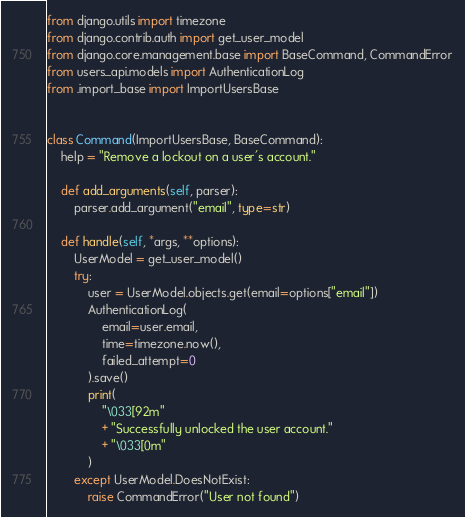<code> <loc_0><loc_0><loc_500><loc_500><_Python_>from django.utils import timezone
from django.contrib.auth import get_user_model
from django.core.management.base import BaseCommand, CommandError
from users_api.models import AuthenticationLog
from .import_base import ImportUsersBase


class Command(ImportUsersBase, BaseCommand):
    help = "Remove a lockout on a user's account."

    def add_arguments(self, parser):
        parser.add_argument("email", type=str)

    def handle(self, *args, **options):
        UserModel = get_user_model()
        try:
            user = UserModel.objects.get(email=options["email"])
            AuthenticationLog(
                email=user.email,
                time=timezone.now(),
                failed_attempt=0
            ).save()
            print(
                "\033[92m"
                + "Successfully unlocked the user account."
                + "\033[0m"
            )
        except UserModel.DoesNotExist:
            raise CommandError("User not found")
</code> 